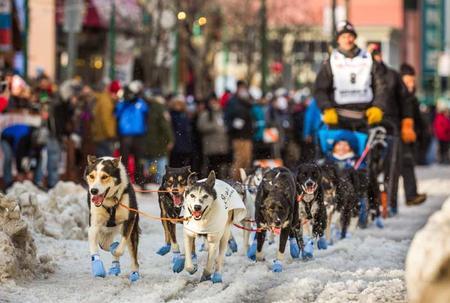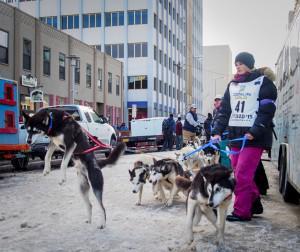The first image is the image on the left, the second image is the image on the right. Evaluate the accuracy of this statement regarding the images: "A person riding the sled is waving.". Is it true? Answer yes or no. No. The first image is the image on the left, the second image is the image on the right. For the images displayed, is the sentence "One image shows a team of dogs in matching bright-colored booties moving leftward in front of people lining the street." factually correct? Answer yes or no. Yes. 